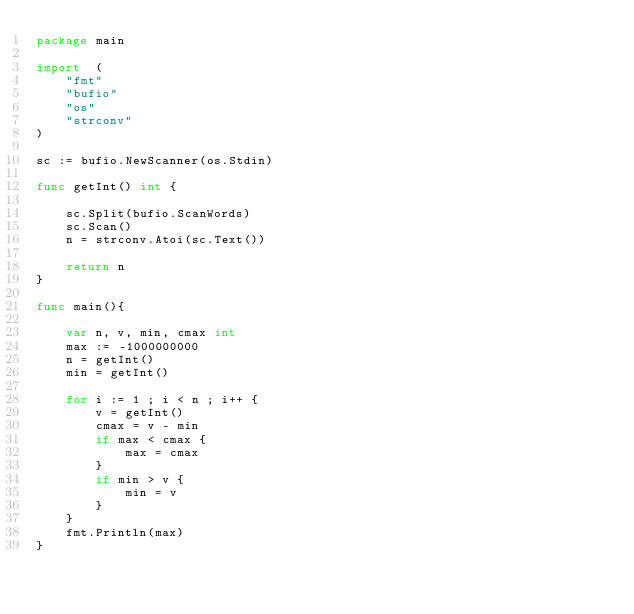<code> <loc_0><loc_0><loc_500><loc_500><_Go_>package main

import  (
    "fmt"
    "bufio"
    "os"
    "strconv"
)

sc := bufio.NewScanner(os.Stdin)

func getInt() int {

    sc.Split(bufio.ScanWords)
    sc.Scan()
    n = strconv.Atoi(sc.Text())
  
    return n
}

func main(){

    var n, v, min, cmax int
    max := -1000000000
    n = getInt()
    min = getInt()

    for i := 1 ; i < n ; i++ {
        v = getInt()
        cmax = v - min
        if max < cmax {
            max = cmax
        }
        if min > v {
            min = v
        }
    }
    fmt.Println(max)
}

</code> 